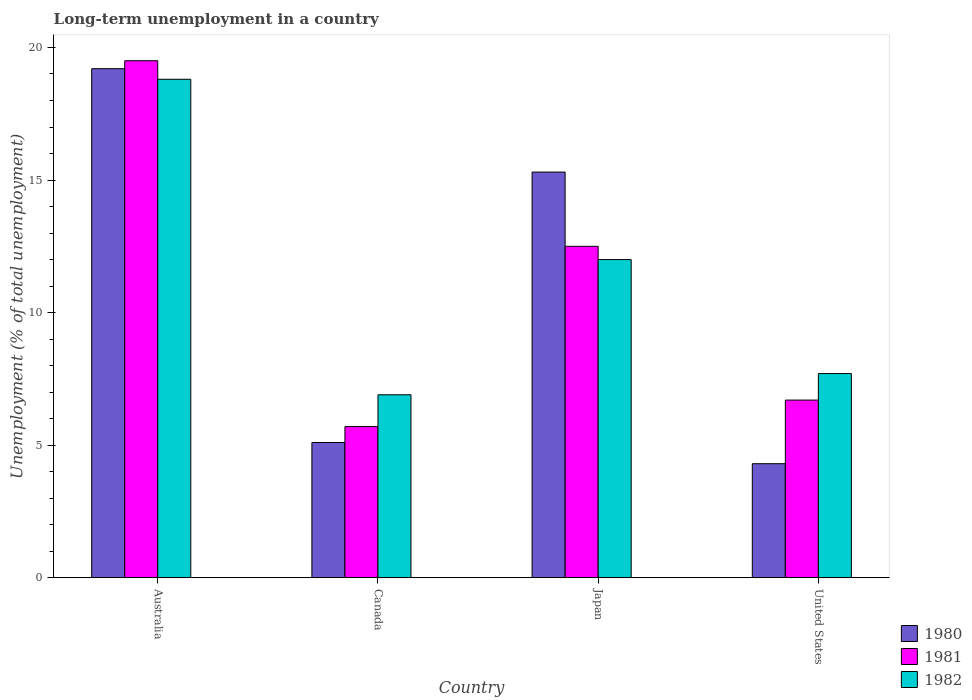How many different coloured bars are there?
Give a very brief answer. 3. Are the number of bars per tick equal to the number of legend labels?
Give a very brief answer. Yes. How many bars are there on the 2nd tick from the left?
Your response must be concise. 3. In how many cases, is the number of bars for a given country not equal to the number of legend labels?
Provide a short and direct response. 0. What is the percentage of long-term unemployed population in 1980 in Australia?
Offer a very short reply. 19.2. Across all countries, what is the maximum percentage of long-term unemployed population in 1980?
Your answer should be very brief. 19.2. Across all countries, what is the minimum percentage of long-term unemployed population in 1982?
Keep it short and to the point. 6.9. What is the total percentage of long-term unemployed population in 1980 in the graph?
Your response must be concise. 43.9. What is the difference between the percentage of long-term unemployed population in 1981 in Australia and that in Canada?
Your answer should be compact. 13.8. What is the difference between the percentage of long-term unemployed population in 1982 in Canada and the percentage of long-term unemployed population in 1980 in United States?
Your answer should be compact. 2.6. What is the average percentage of long-term unemployed population in 1981 per country?
Give a very brief answer. 11.1. What is the difference between the percentage of long-term unemployed population of/in 1981 and percentage of long-term unemployed population of/in 1980 in Australia?
Your response must be concise. 0.3. In how many countries, is the percentage of long-term unemployed population in 1981 greater than 19 %?
Provide a succinct answer. 1. What is the ratio of the percentage of long-term unemployed population in 1981 in Australia to that in Japan?
Offer a very short reply. 1.56. What is the difference between the highest and the second highest percentage of long-term unemployed population in 1982?
Offer a very short reply. 6.8. What is the difference between the highest and the lowest percentage of long-term unemployed population in 1982?
Give a very brief answer. 11.9. Is the sum of the percentage of long-term unemployed population in 1981 in Australia and Japan greater than the maximum percentage of long-term unemployed population in 1982 across all countries?
Give a very brief answer. Yes. What does the 3rd bar from the left in Canada represents?
Ensure brevity in your answer.  1982. What does the 2nd bar from the right in Australia represents?
Provide a succinct answer. 1981. How many countries are there in the graph?
Your answer should be compact. 4. What is the difference between two consecutive major ticks on the Y-axis?
Your answer should be very brief. 5. Are the values on the major ticks of Y-axis written in scientific E-notation?
Your answer should be very brief. No. Does the graph contain grids?
Your response must be concise. No. How many legend labels are there?
Keep it short and to the point. 3. How are the legend labels stacked?
Your answer should be very brief. Vertical. What is the title of the graph?
Give a very brief answer. Long-term unemployment in a country. What is the label or title of the X-axis?
Provide a succinct answer. Country. What is the label or title of the Y-axis?
Provide a short and direct response. Unemployment (% of total unemployment). What is the Unemployment (% of total unemployment) in 1980 in Australia?
Make the answer very short. 19.2. What is the Unemployment (% of total unemployment) of 1981 in Australia?
Offer a terse response. 19.5. What is the Unemployment (% of total unemployment) of 1982 in Australia?
Provide a succinct answer. 18.8. What is the Unemployment (% of total unemployment) of 1980 in Canada?
Your answer should be compact. 5.1. What is the Unemployment (% of total unemployment) in 1981 in Canada?
Offer a very short reply. 5.7. What is the Unemployment (% of total unemployment) of 1982 in Canada?
Your response must be concise. 6.9. What is the Unemployment (% of total unemployment) of 1980 in Japan?
Offer a terse response. 15.3. What is the Unemployment (% of total unemployment) in 1981 in Japan?
Keep it short and to the point. 12.5. What is the Unemployment (% of total unemployment) of 1980 in United States?
Make the answer very short. 4.3. What is the Unemployment (% of total unemployment) in 1981 in United States?
Provide a short and direct response. 6.7. What is the Unemployment (% of total unemployment) of 1982 in United States?
Your answer should be very brief. 7.7. Across all countries, what is the maximum Unemployment (% of total unemployment) of 1980?
Make the answer very short. 19.2. Across all countries, what is the maximum Unemployment (% of total unemployment) of 1982?
Your answer should be compact. 18.8. Across all countries, what is the minimum Unemployment (% of total unemployment) of 1980?
Your answer should be very brief. 4.3. Across all countries, what is the minimum Unemployment (% of total unemployment) of 1981?
Your response must be concise. 5.7. Across all countries, what is the minimum Unemployment (% of total unemployment) in 1982?
Offer a very short reply. 6.9. What is the total Unemployment (% of total unemployment) in 1980 in the graph?
Provide a short and direct response. 43.9. What is the total Unemployment (% of total unemployment) in 1981 in the graph?
Give a very brief answer. 44.4. What is the total Unemployment (% of total unemployment) in 1982 in the graph?
Your response must be concise. 45.4. What is the difference between the Unemployment (% of total unemployment) of 1982 in Australia and that in Canada?
Your answer should be very brief. 11.9. What is the difference between the Unemployment (% of total unemployment) in 1980 in Australia and that in Japan?
Ensure brevity in your answer.  3.9. What is the difference between the Unemployment (% of total unemployment) of 1981 in Australia and that in United States?
Offer a very short reply. 12.8. What is the difference between the Unemployment (% of total unemployment) of 1982 in Australia and that in United States?
Your answer should be compact. 11.1. What is the difference between the Unemployment (% of total unemployment) of 1981 in Canada and that in Japan?
Ensure brevity in your answer.  -6.8. What is the difference between the Unemployment (% of total unemployment) of 1982 in Canada and that in Japan?
Provide a short and direct response. -5.1. What is the difference between the Unemployment (% of total unemployment) of 1980 in Canada and that in United States?
Give a very brief answer. 0.8. What is the difference between the Unemployment (% of total unemployment) in 1980 in Japan and that in United States?
Make the answer very short. 11. What is the difference between the Unemployment (% of total unemployment) of 1981 in Japan and that in United States?
Make the answer very short. 5.8. What is the difference between the Unemployment (% of total unemployment) of 1982 in Japan and that in United States?
Your answer should be very brief. 4.3. What is the difference between the Unemployment (% of total unemployment) of 1980 in Australia and the Unemployment (% of total unemployment) of 1981 in Canada?
Your answer should be compact. 13.5. What is the difference between the Unemployment (% of total unemployment) in 1981 in Australia and the Unemployment (% of total unemployment) in 1982 in Canada?
Your response must be concise. 12.6. What is the difference between the Unemployment (% of total unemployment) of 1981 in Australia and the Unemployment (% of total unemployment) of 1982 in United States?
Provide a succinct answer. 11.8. What is the difference between the Unemployment (% of total unemployment) in 1980 in Canada and the Unemployment (% of total unemployment) in 1981 in Japan?
Provide a short and direct response. -7.4. What is the difference between the Unemployment (% of total unemployment) of 1981 in Canada and the Unemployment (% of total unemployment) of 1982 in Japan?
Keep it short and to the point. -6.3. What is the difference between the Unemployment (% of total unemployment) in 1981 in Canada and the Unemployment (% of total unemployment) in 1982 in United States?
Offer a very short reply. -2. What is the difference between the Unemployment (% of total unemployment) of 1980 in Japan and the Unemployment (% of total unemployment) of 1982 in United States?
Your answer should be very brief. 7.6. What is the average Unemployment (% of total unemployment) in 1980 per country?
Ensure brevity in your answer.  10.97. What is the average Unemployment (% of total unemployment) in 1981 per country?
Keep it short and to the point. 11.1. What is the average Unemployment (% of total unemployment) of 1982 per country?
Your answer should be very brief. 11.35. What is the difference between the Unemployment (% of total unemployment) in 1980 and Unemployment (% of total unemployment) in 1981 in Australia?
Ensure brevity in your answer.  -0.3. What is the difference between the Unemployment (% of total unemployment) in 1980 and Unemployment (% of total unemployment) in 1982 in Australia?
Make the answer very short. 0.4. What is the difference between the Unemployment (% of total unemployment) of 1981 and Unemployment (% of total unemployment) of 1982 in Australia?
Offer a terse response. 0.7. What is the difference between the Unemployment (% of total unemployment) in 1980 and Unemployment (% of total unemployment) in 1982 in Canada?
Ensure brevity in your answer.  -1.8. What is the difference between the Unemployment (% of total unemployment) of 1980 and Unemployment (% of total unemployment) of 1981 in Japan?
Your response must be concise. 2.8. What is the difference between the Unemployment (% of total unemployment) of 1980 and Unemployment (% of total unemployment) of 1982 in United States?
Keep it short and to the point. -3.4. What is the ratio of the Unemployment (% of total unemployment) in 1980 in Australia to that in Canada?
Your answer should be very brief. 3.76. What is the ratio of the Unemployment (% of total unemployment) in 1981 in Australia to that in Canada?
Offer a very short reply. 3.42. What is the ratio of the Unemployment (% of total unemployment) in 1982 in Australia to that in Canada?
Ensure brevity in your answer.  2.72. What is the ratio of the Unemployment (% of total unemployment) of 1980 in Australia to that in Japan?
Offer a very short reply. 1.25. What is the ratio of the Unemployment (% of total unemployment) in 1981 in Australia to that in Japan?
Your answer should be very brief. 1.56. What is the ratio of the Unemployment (% of total unemployment) of 1982 in Australia to that in Japan?
Your response must be concise. 1.57. What is the ratio of the Unemployment (% of total unemployment) of 1980 in Australia to that in United States?
Make the answer very short. 4.47. What is the ratio of the Unemployment (% of total unemployment) in 1981 in Australia to that in United States?
Provide a succinct answer. 2.91. What is the ratio of the Unemployment (% of total unemployment) in 1982 in Australia to that in United States?
Ensure brevity in your answer.  2.44. What is the ratio of the Unemployment (% of total unemployment) in 1980 in Canada to that in Japan?
Your answer should be very brief. 0.33. What is the ratio of the Unemployment (% of total unemployment) in 1981 in Canada to that in Japan?
Ensure brevity in your answer.  0.46. What is the ratio of the Unemployment (% of total unemployment) in 1982 in Canada to that in Japan?
Keep it short and to the point. 0.57. What is the ratio of the Unemployment (% of total unemployment) in 1980 in Canada to that in United States?
Offer a terse response. 1.19. What is the ratio of the Unemployment (% of total unemployment) in 1981 in Canada to that in United States?
Provide a succinct answer. 0.85. What is the ratio of the Unemployment (% of total unemployment) in 1982 in Canada to that in United States?
Ensure brevity in your answer.  0.9. What is the ratio of the Unemployment (% of total unemployment) in 1980 in Japan to that in United States?
Give a very brief answer. 3.56. What is the ratio of the Unemployment (% of total unemployment) of 1981 in Japan to that in United States?
Give a very brief answer. 1.87. What is the ratio of the Unemployment (% of total unemployment) of 1982 in Japan to that in United States?
Your response must be concise. 1.56. What is the difference between the highest and the lowest Unemployment (% of total unemployment) in 1982?
Provide a succinct answer. 11.9. 